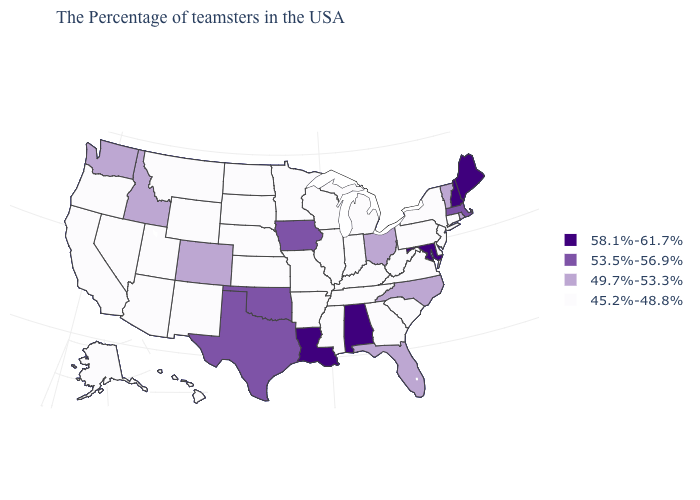What is the highest value in the USA?
Give a very brief answer. 58.1%-61.7%. What is the lowest value in the West?
Short answer required. 45.2%-48.8%. What is the value of California?
Give a very brief answer. 45.2%-48.8%. Does Nevada have the same value as New Jersey?
Short answer required. Yes. Does Colorado have the lowest value in the West?
Quick response, please. No. What is the value of Louisiana?
Short answer required. 58.1%-61.7%. Which states have the lowest value in the USA?
Short answer required. Connecticut, New York, New Jersey, Delaware, Pennsylvania, Virginia, South Carolina, West Virginia, Georgia, Michigan, Kentucky, Indiana, Tennessee, Wisconsin, Illinois, Mississippi, Missouri, Arkansas, Minnesota, Kansas, Nebraska, South Dakota, North Dakota, Wyoming, New Mexico, Utah, Montana, Arizona, Nevada, California, Oregon, Alaska, Hawaii. Does the first symbol in the legend represent the smallest category?
Give a very brief answer. No. What is the value of North Carolina?
Answer briefly. 49.7%-53.3%. Is the legend a continuous bar?
Be succinct. No. Among the states that border Utah , which have the lowest value?
Answer briefly. Wyoming, New Mexico, Arizona, Nevada. What is the lowest value in the USA?
Keep it brief. 45.2%-48.8%. What is the highest value in the MidWest ?
Concise answer only. 53.5%-56.9%. Does the first symbol in the legend represent the smallest category?
Concise answer only. No. What is the value of Oregon?
Give a very brief answer. 45.2%-48.8%. 